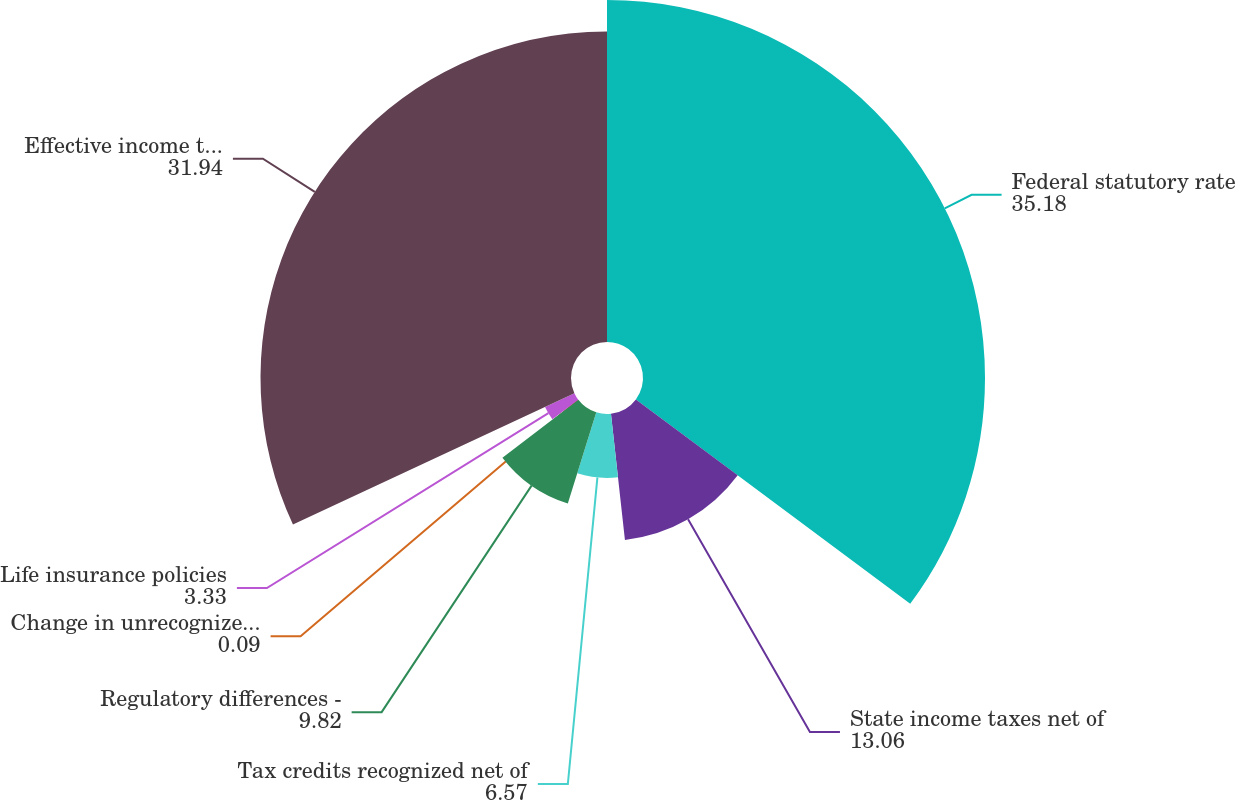<chart> <loc_0><loc_0><loc_500><loc_500><pie_chart><fcel>Federal statutory rate<fcel>State income taxes net of<fcel>Tax credits recognized net of<fcel>Regulatory differences -<fcel>Change in unrecognized tax<fcel>Life insurance policies<fcel>Effective income tax rate from<nl><fcel>35.18%<fcel>13.06%<fcel>6.57%<fcel>9.82%<fcel>0.09%<fcel>3.33%<fcel>31.94%<nl></chart> 